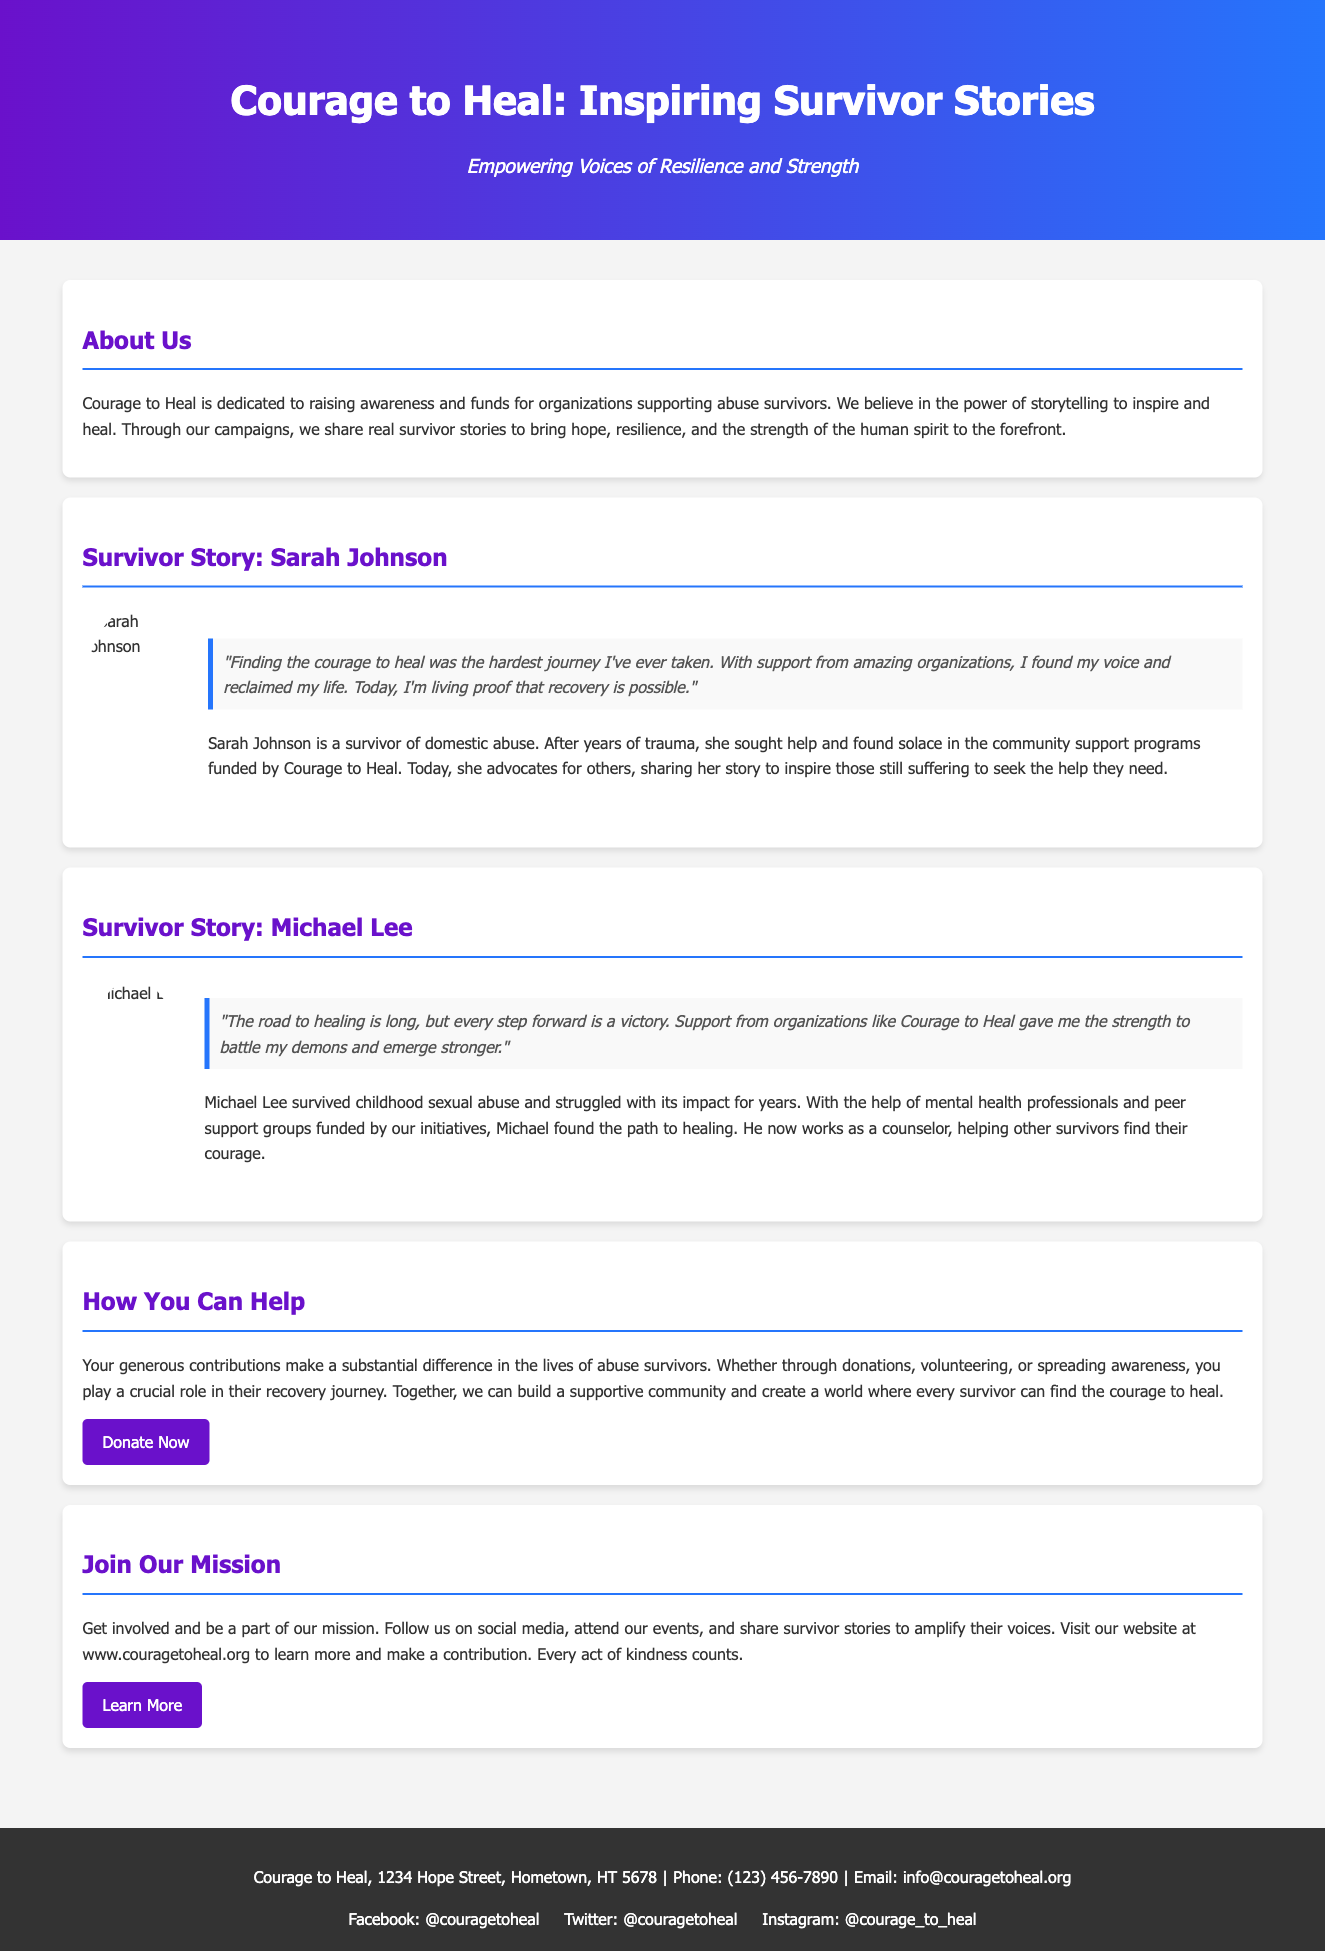What is the title of the advertisement? The title appears prominently at the top of the document, stating the focus of the advertisement.
Answer: Courage to Heal: Inspiring Survivor Stories Who is the first survivor featured in the advertisement? The first survivor mentioned in the document is introduced in a dedicated section highlighting their story.
Answer: Sarah Johnson What color is the background of the header? The background of the header features a gradient with specific colors that create a striking visual.
Answer: Gradient from purple to blue What type of support did Michael Lee receive? Michael Lee's story includes details about the support services that aided his healing process, which are emphasized in the document.
Answer: Mental health professionals and peer support groups What is the primary call to action in the advertisement? The advertisement encourages readers to take action through a specific invitation found towards the end.
Answer: Donate Now Why does Courage to Heal believe in storytelling? The document explains the philosophy behind the organization and its approach to raising awareness, which includes storytelling.
Answer: To inspire and heal What is Michael Lee's current profession? The document mentions Michael Lee's career after his experience, showcasing his commitment to helping others.
Answer: Counselor How can individuals help the cause mentioned in the advertisement? The document outlines several ways a person can get involved or support the mission, which is clearly stated within a section.
Answer: Donations, volunteering, or spreading awareness What is the website URL for Courage to Heal? The advertisement provides specific contact information, including the website for those who want more details.
Answer: www.couragetoheal.org 